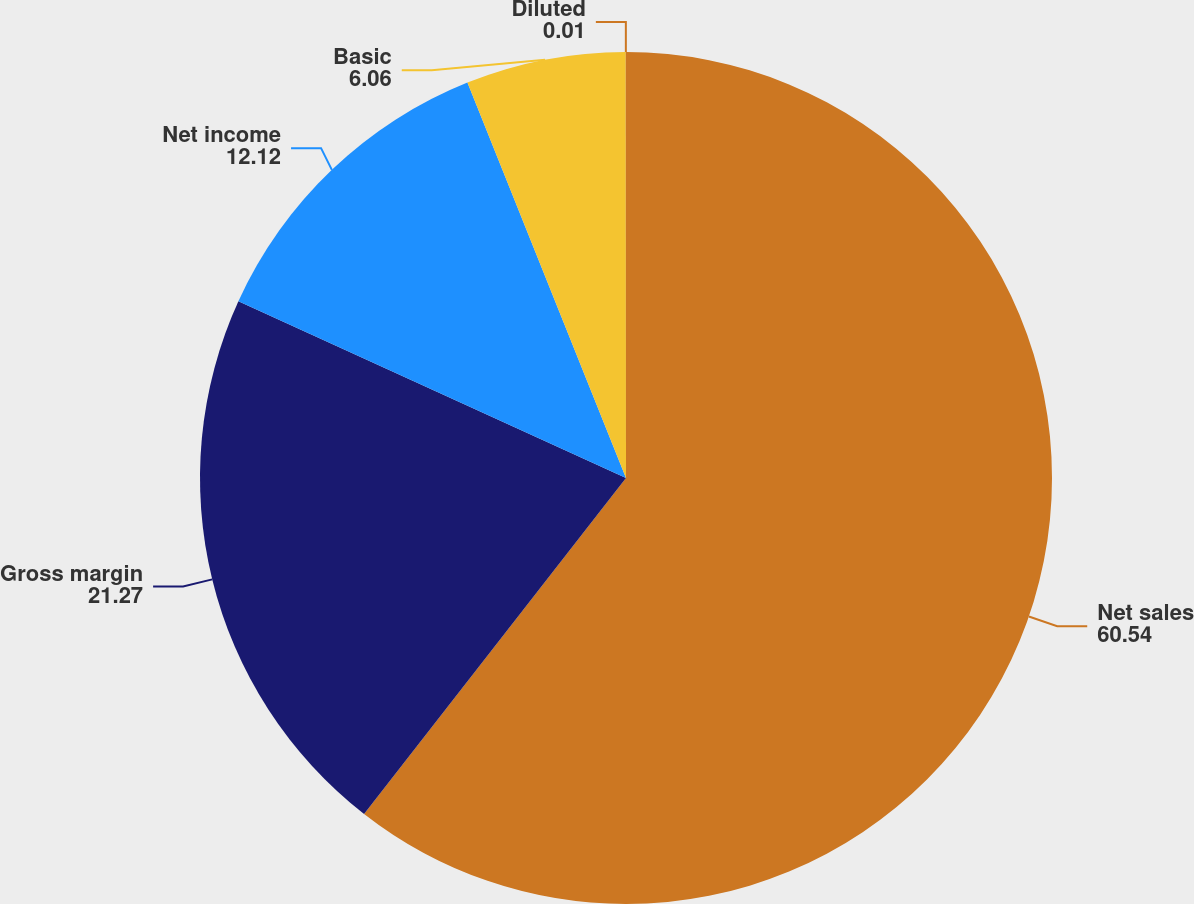<chart> <loc_0><loc_0><loc_500><loc_500><pie_chart><fcel>Net sales<fcel>Gross margin<fcel>Net income<fcel>Basic<fcel>Diluted<nl><fcel>60.54%<fcel>21.27%<fcel>12.12%<fcel>6.06%<fcel>0.01%<nl></chart> 